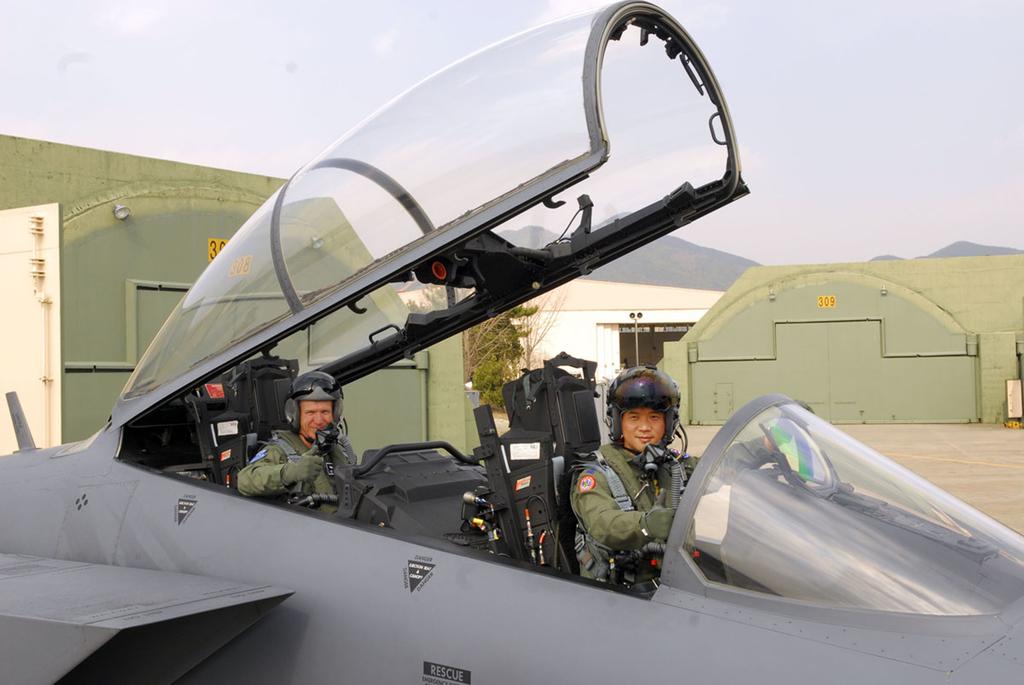What is written in the black rectangles on the plane?
Your response must be concise. Rescue. What is the number in yellow on the right bulding?
Ensure brevity in your answer.  309. 